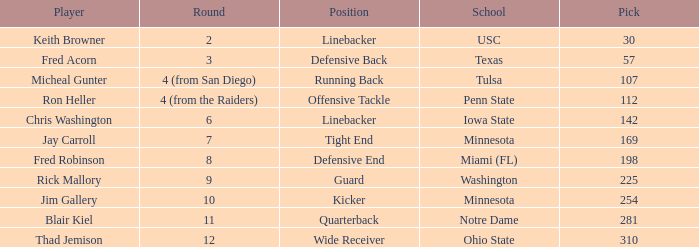What is Thad Jemison's position? Wide Receiver. 